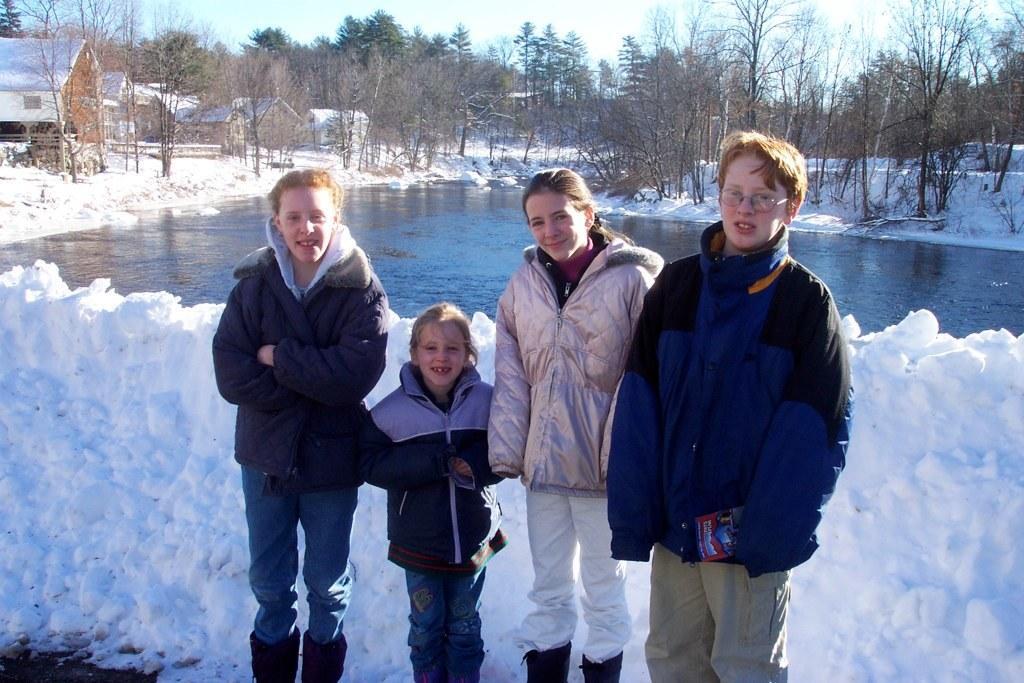How would you summarize this image in a sentence or two? There are four people standing,behind these people we can see snow and we can see water. In the background we can see trees,houses and sky. 